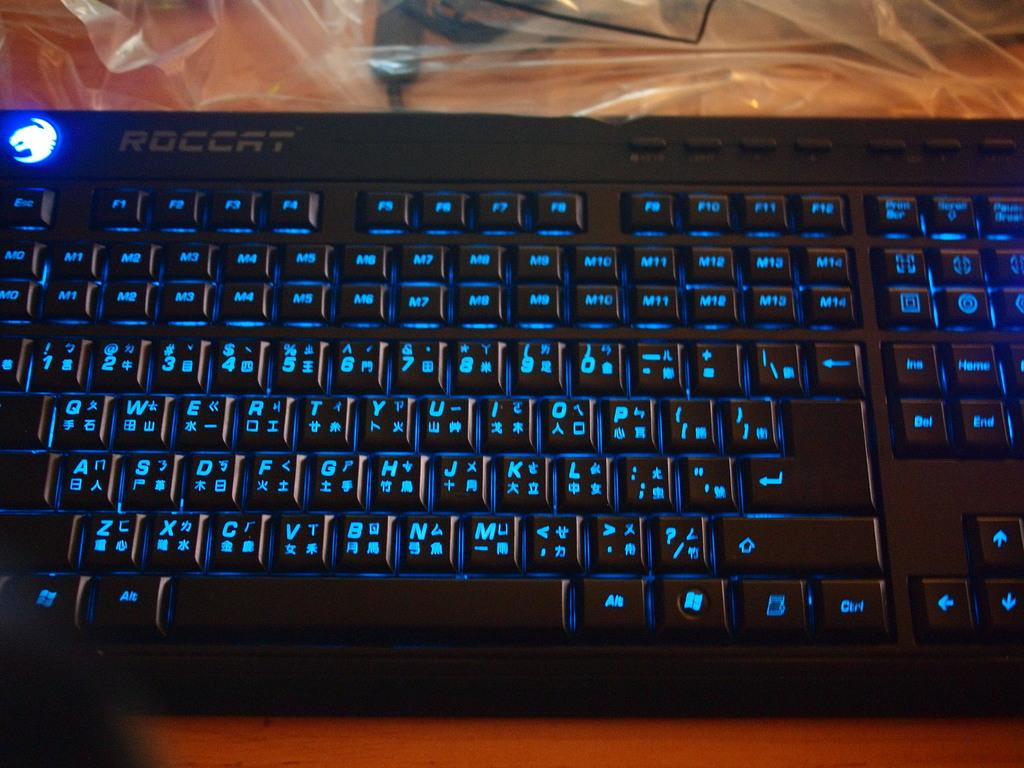What electronic device is visible in the image? There is a keyboard in the image. What is covering the keyboard in the image? There is a cover in the image. Where are the keyboard and cover located? The keyboard and cover are placed on a table. How many eggs are on the keyboard in the image? There are no eggs present on the keyboard in the image. 